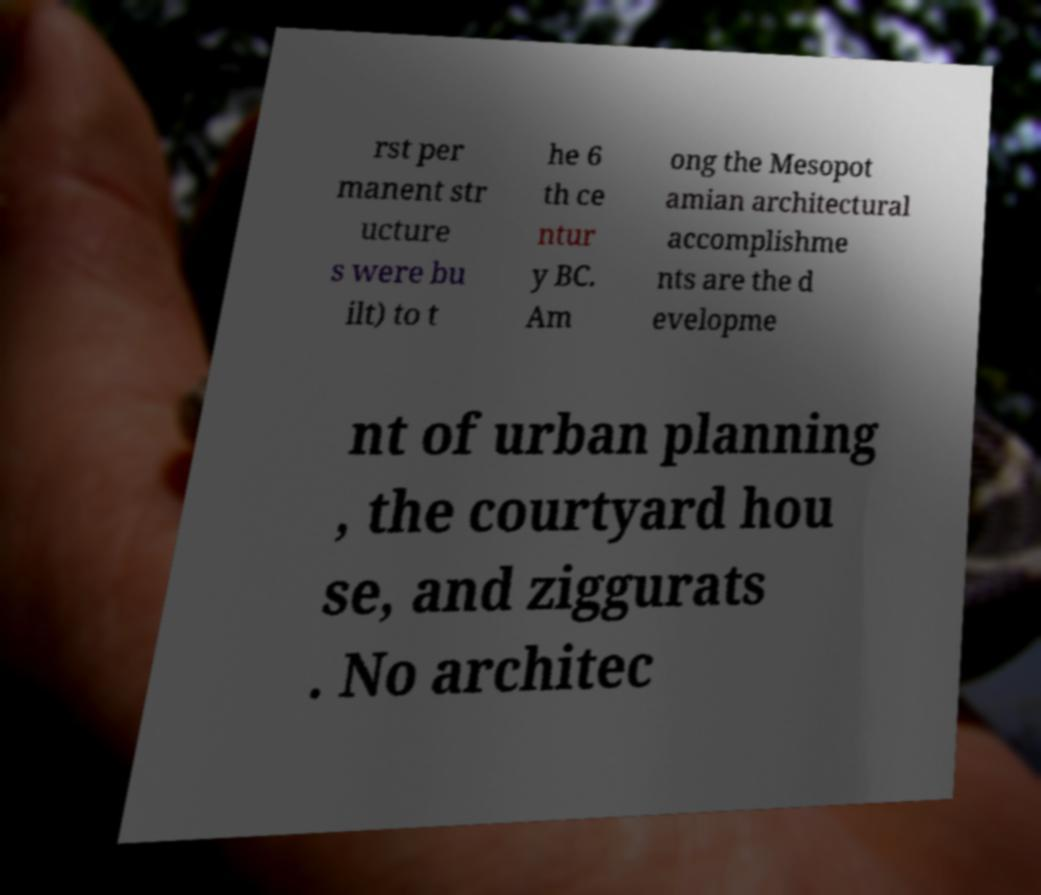Please read and relay the text visible in this image. What does it say? rst per manent str ucture s were bu ilt) to t he 6 th ce ntur y BC. Am ong the Mesopot amian architectural accomplishme nts are the d evelopme nt of urban planning , the courtyard hou se, and ziggurats . No architec 